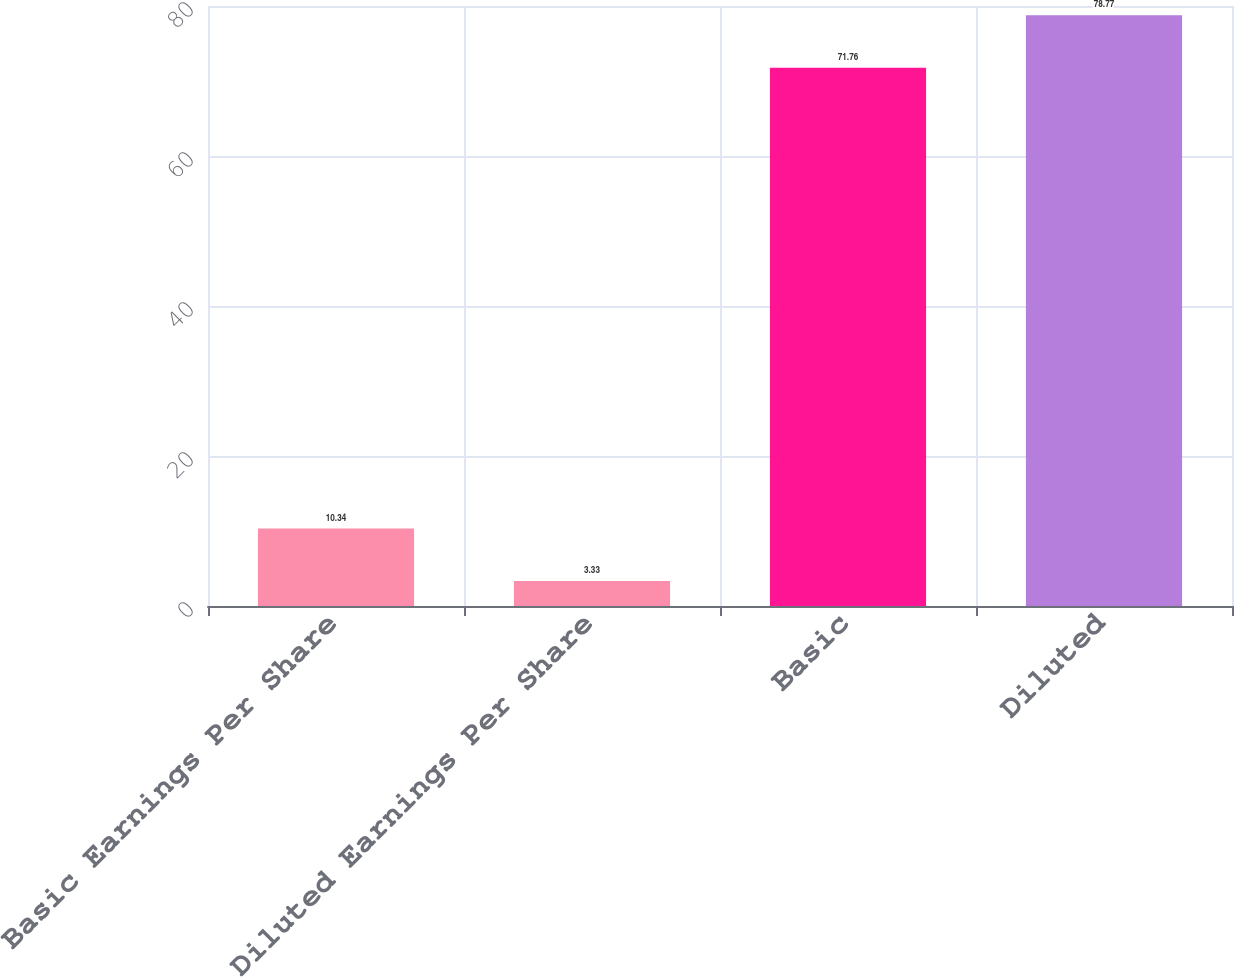<chart> <loc_0><loc_0><loc_500><loc_500><bar_chart><fcel>Basic Earnings Per Share<fcel>Diluted Earnings Per Share<fcel>Basic<fcel>Diluted<nl><fcel>10.34<fcel>3.33<fcel>71.76<fcel>78.77<nl></chart> 